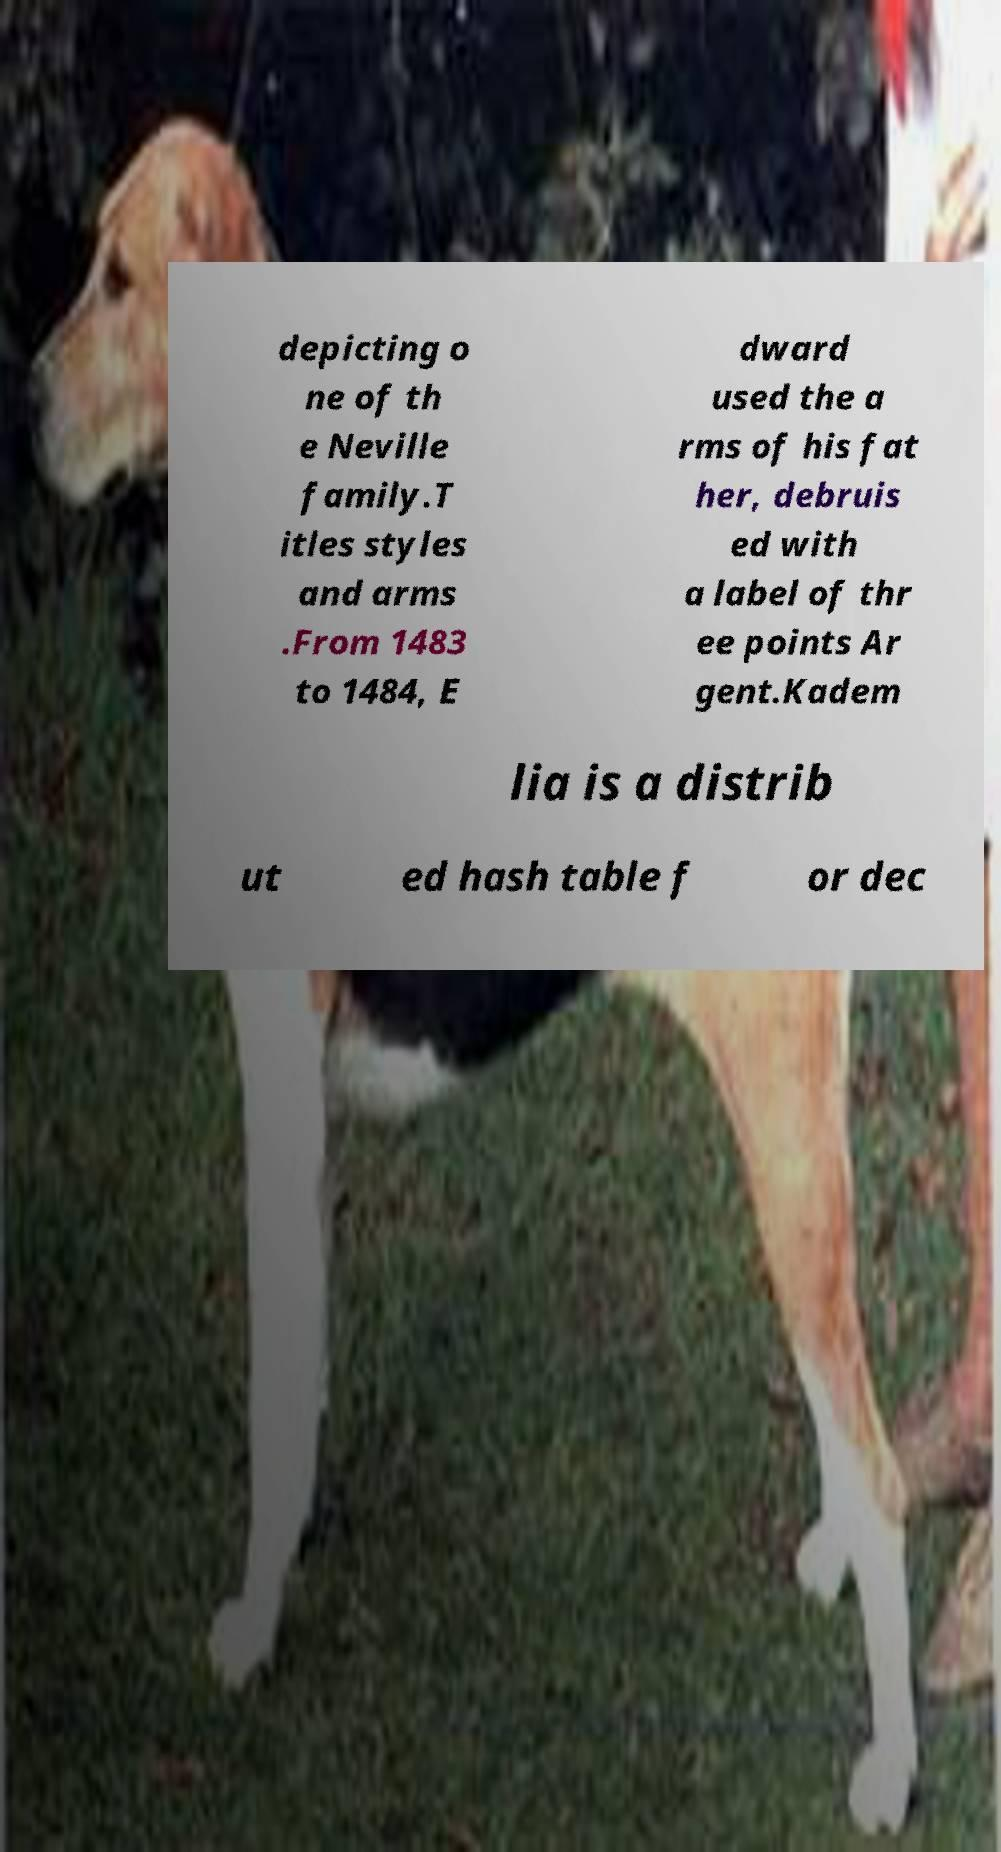Can you read and provide the text displayed in the image?This photo seems to have some interesting text. Can you extract and type it out for me? depicting o ne of th e Neville family.T itles styles and arms .From 1483 to 1484, E dward used the a rms of his fat her, debruis ed with a label of thr ee points Ar gent.Kadem lia is a distrib ut ed hash table f or dec 